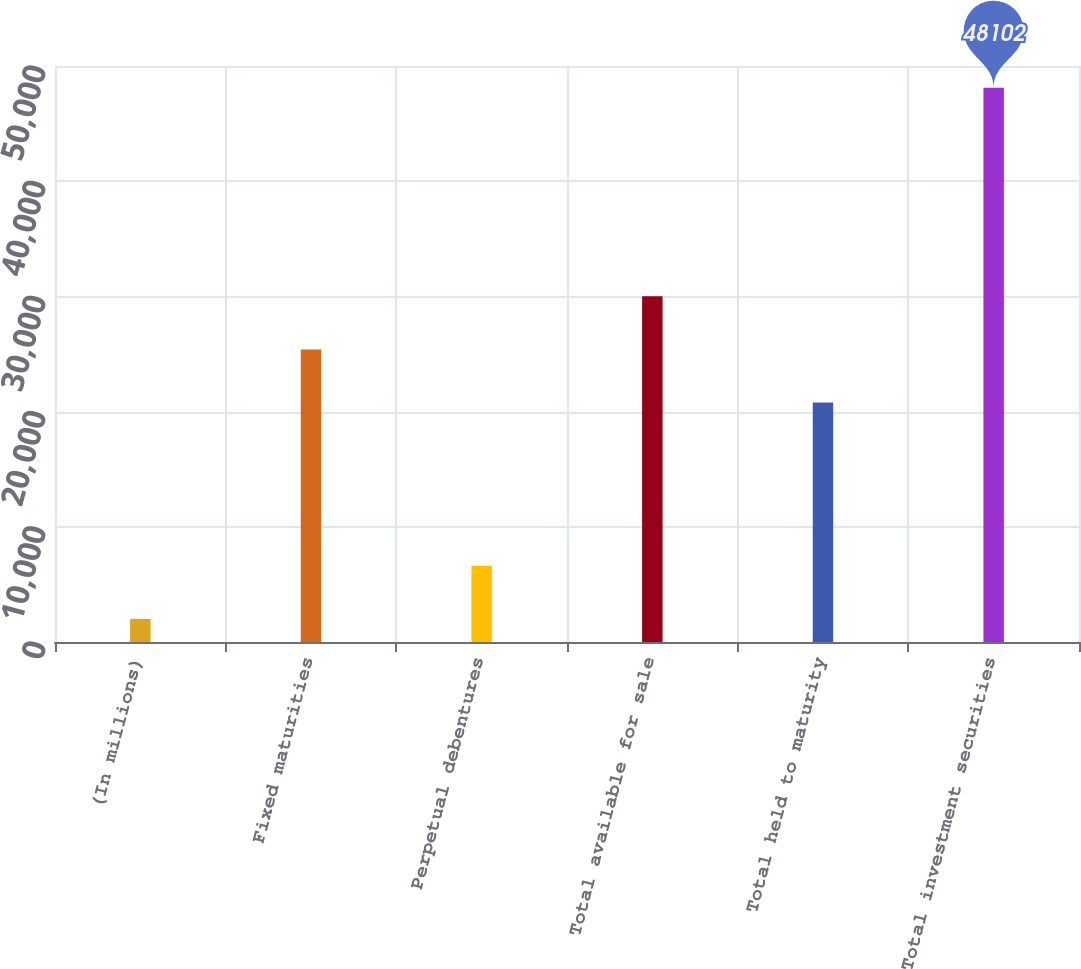Convert chart to OTSL. <chart><loc_0><loc_0><loc_500><loc_500><bar_chart><fcel>(In millions)<fcel>Fixed maturities<fcel>Perpetual debentures<fcel>Total available for sale<fcel>Total held to maturity<fcel>Total investment securities<nl><fcel>2007<fcel>25393.5<fcel>6616.5<fcel>30003<fcel>20784<fcel>48102<nl></chart> 